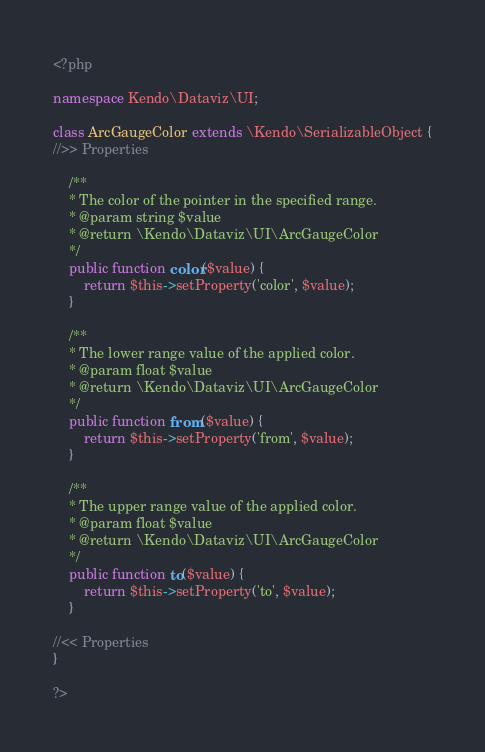Convert code to text. <code><loc_0><loc_0><loc_500><loc_500><_PHP_><?php

namespace Kendo\Dataviz\UI;

class ArcGaugeColor extends \Kendo\SerializableObject {
//>> Properties

    /**
    * The color of the pointer in the specified range.
    * @param string $value
    * @return \Kendo\Dataviz\UI\ArcGaugeColor
    */
    public function color($value) {
        return $this->setProperty('color', $value);
    }

    /**
    * The lower range value of the applied color.
    * @param float $value
    * @return \Kendo\Dataviz\UI\ArcGaugeColor
    */
    public function from($value) {
        return $this->setProperty('from', $value);
    }

    /**
    * The upper range value of the applied color.
    * @param float $value
    * @return \Kendo\Dataviz\UI\ArcGaugeColor
    */
    public function to($value) {
        return $this->setProperty('to', $value);
    }

//<< Properties
}

?>
</code> 